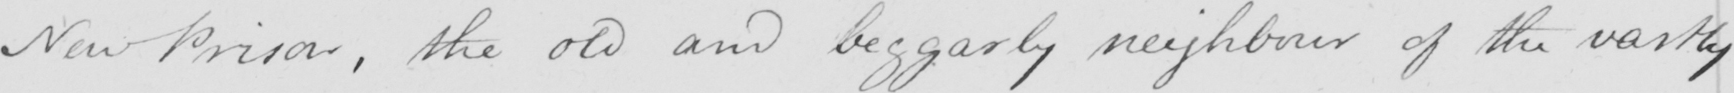Transcribe the text shown in this historical manuscript line. New Prison , the old and beggarly neighbour of the vastly 